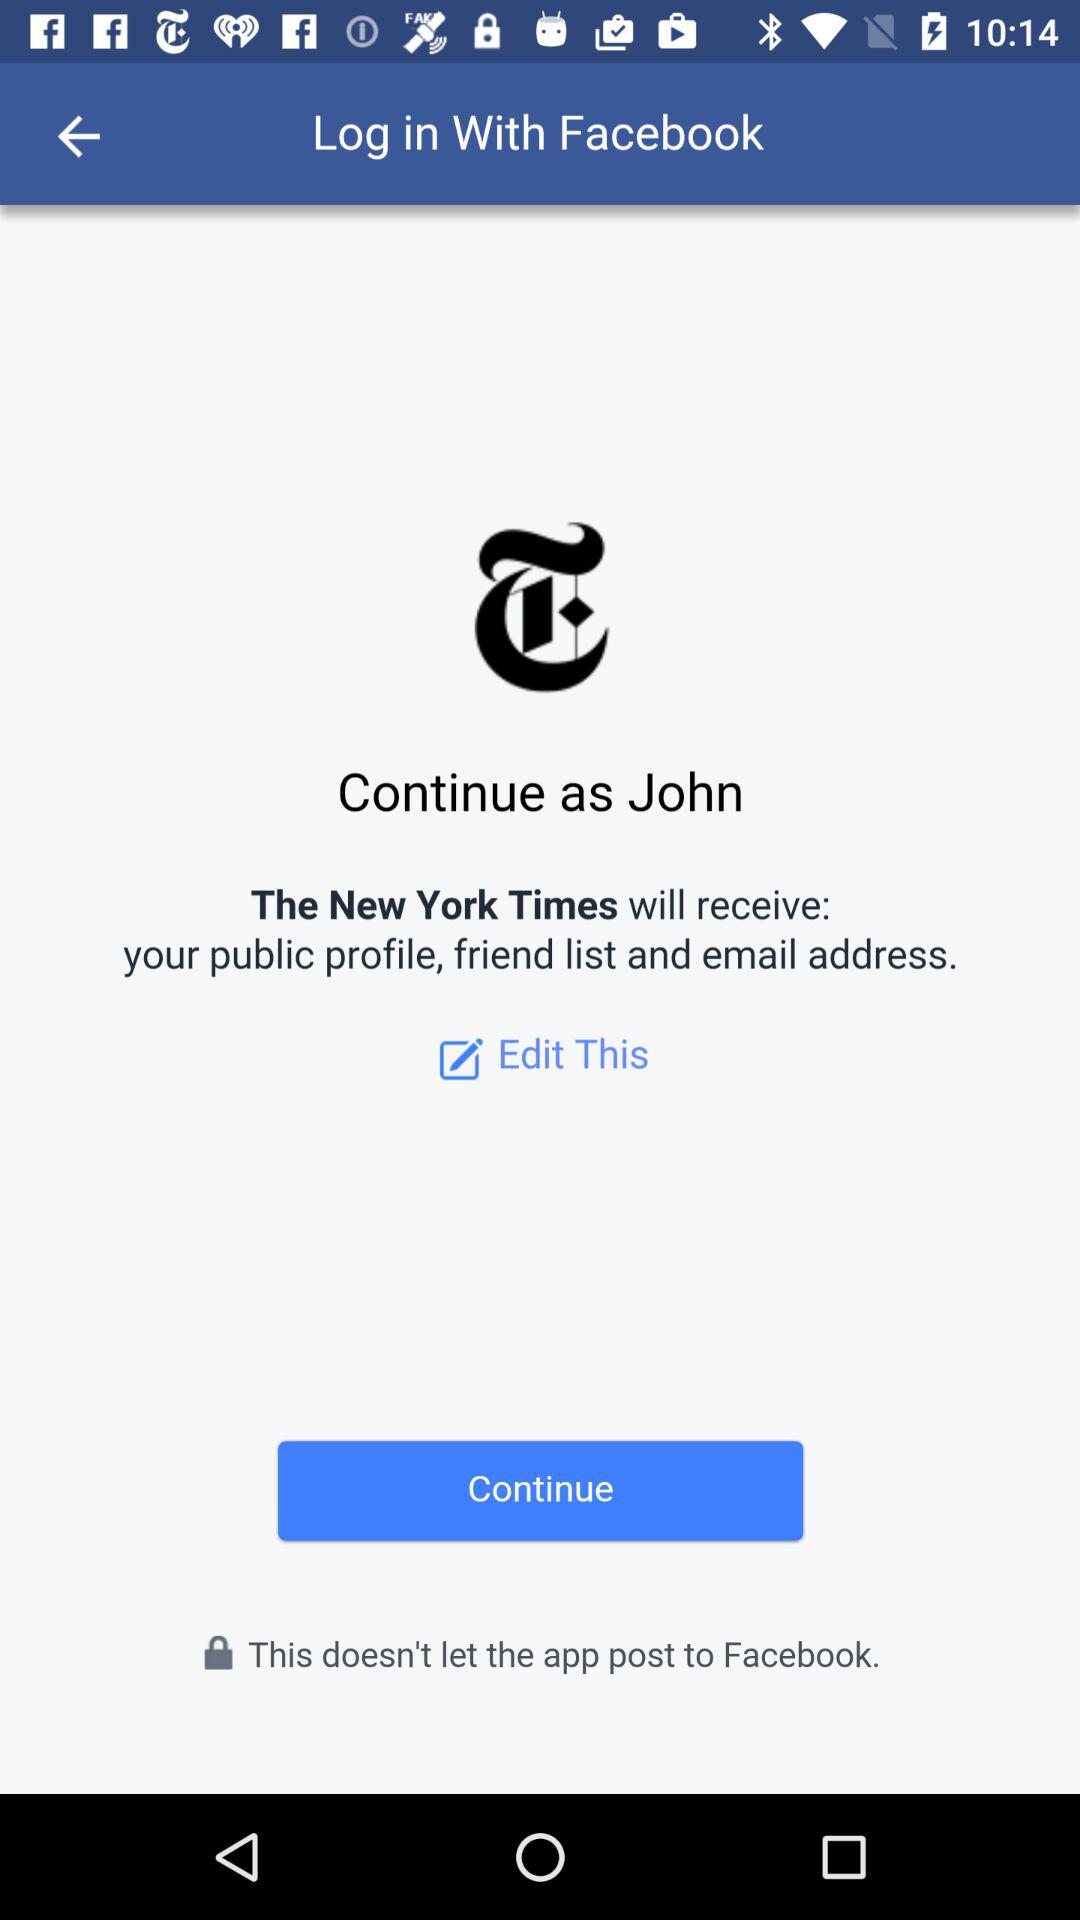What application is asking for permission? The application that is asking for permission is "The New York Times". 